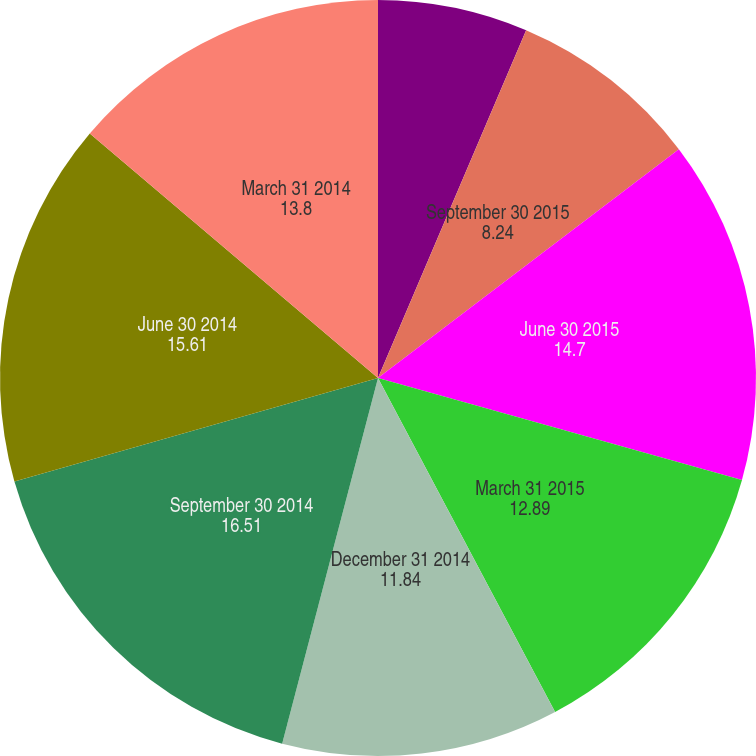Convert chart to OTSL. <chart><loc_0><loc_0><loc_500><loc_500><pie_chart><fcel>December 31 2015<fcel>September 30 2015<fcel>June 30 2015<fcel>March 31 2015<fcel>December 31 2014<fcel>September 30 2014<fcel>June 30 2014<fcel>March 31 2014<nl><fcel>6.41%<fcel>8.24%<fcel>14.7%<fcel>12.89%<fcel>11.84%<fcel>16.51%<fcel>15.61%<fcel>13.8%<nl></chart> 